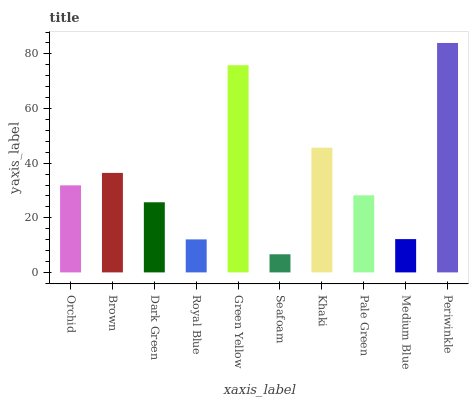Is Seafoam the minimum?
Answer yes or no. Yes. Is Periwinkle the maximum?
Answer yes or no. Yes. Is Brown the minimum?
Answer yes or no. No. Is Brown the maximum?
Answer yes or no. No. Is Brown greater than Orchid?
Answer yes or no. Yes. Is Orchid less than Brown?
Answer yes or no. Yes. Is Orchid greater than Brown?
Answer yes or no. No. Is Brown less than Orchid?
Answer yes or no. No. Is Orchid the high median?
Answer yes or no. Yes. Is Pale Green the low median?
Answer yes or no. Yes. Is Brown the high median?
Answer yes or no. No. Is Medium Blue the low median?
Answer yes or no. No. 